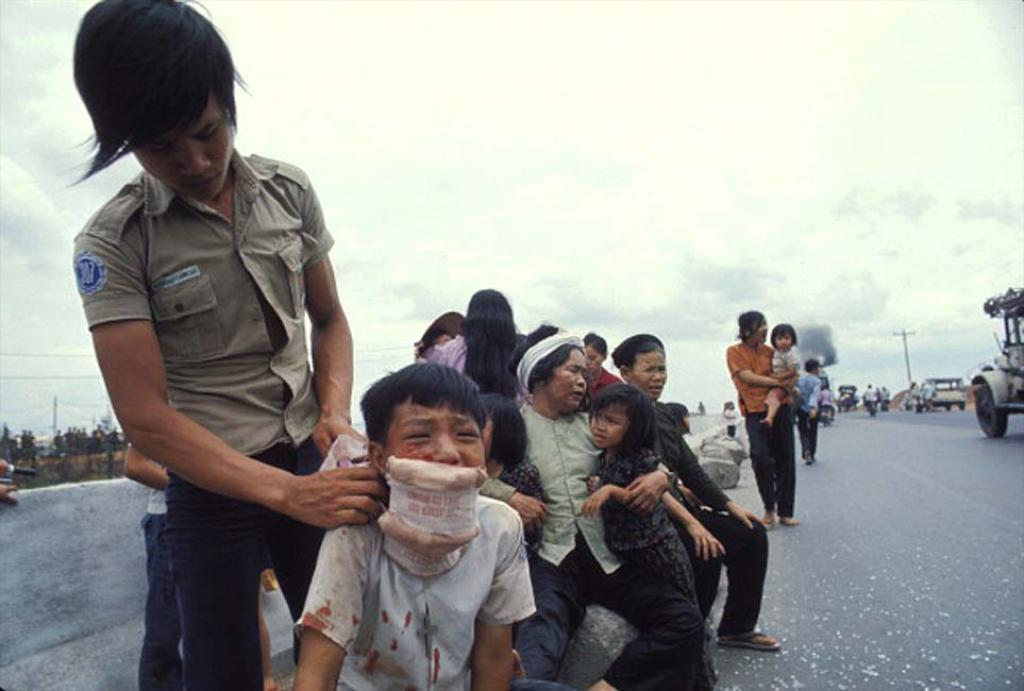Who or what can be seen in the image? There are people and vehicles in the image. What type of environment is depicted in the image? The image shows a road and trees, suggesting an outdoor setting. What is visible in the background of the image? The sky is visible in the background of the image. What type of mine can be seen in the image? There is no mine present in the image. How does the feeling of the people in the image change throughout the day? The image does not provide information about the feelings of the people, so it cannot be determined how their feelings change throughout the day. 